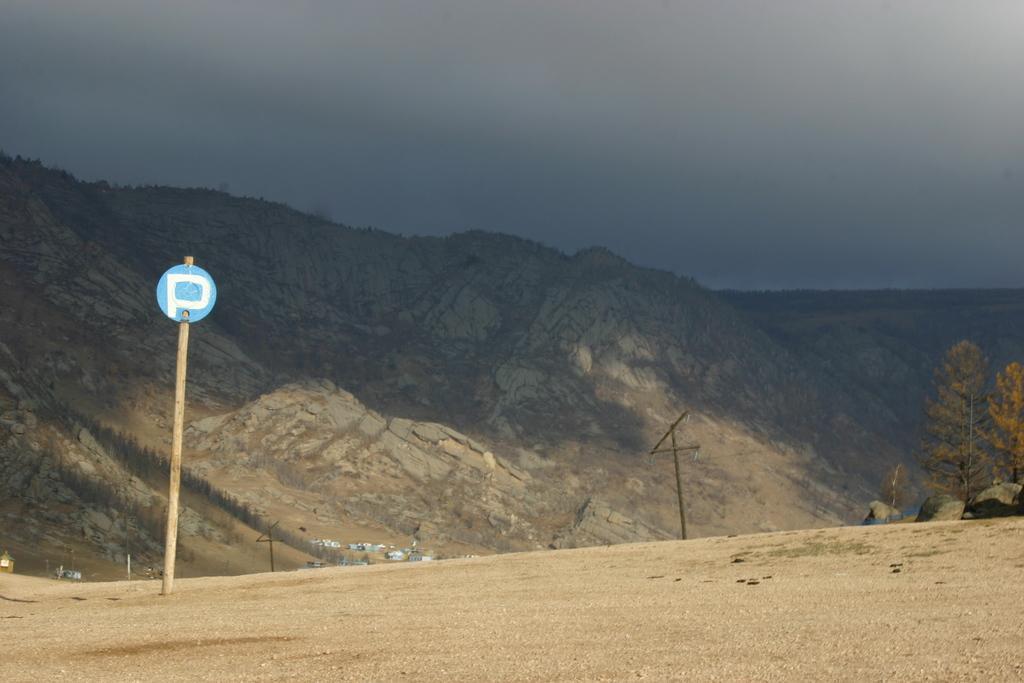Can you describe this image briefly? In the picture we can see the hill surface with a pole and board to it and besides, we can see some trees and in the background we can see the rocky hills and the sky. 